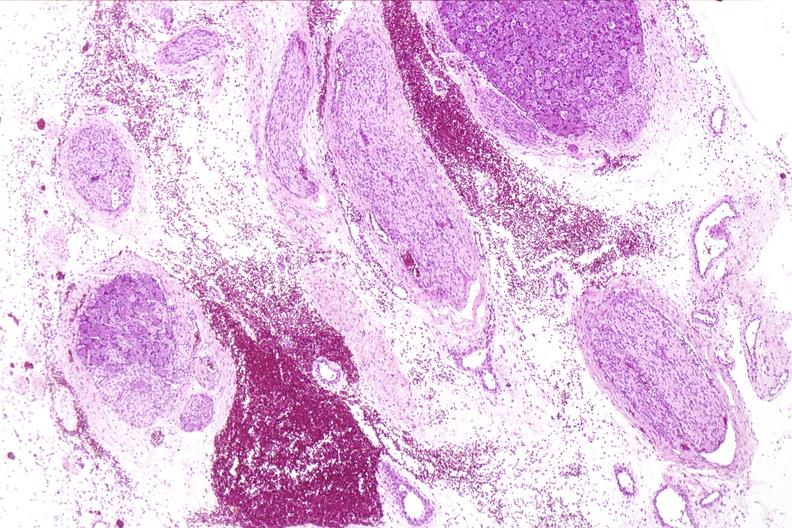s metastatic colon cancer present?
Answer the question using a single word or phrase. No 